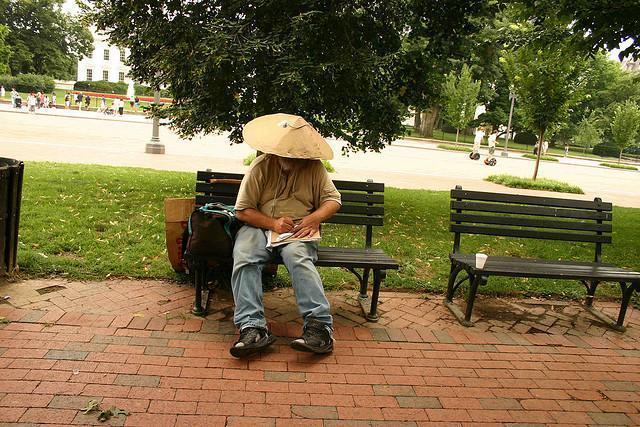How many benches are in the picture?
Give a very brief answer. 2. How many motorcycles are parked off the street?
Give a very brief answer. 0. 